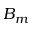<formula> <loc_0><loc_0><loc_500><loc_500>B _ { m }</formula> 